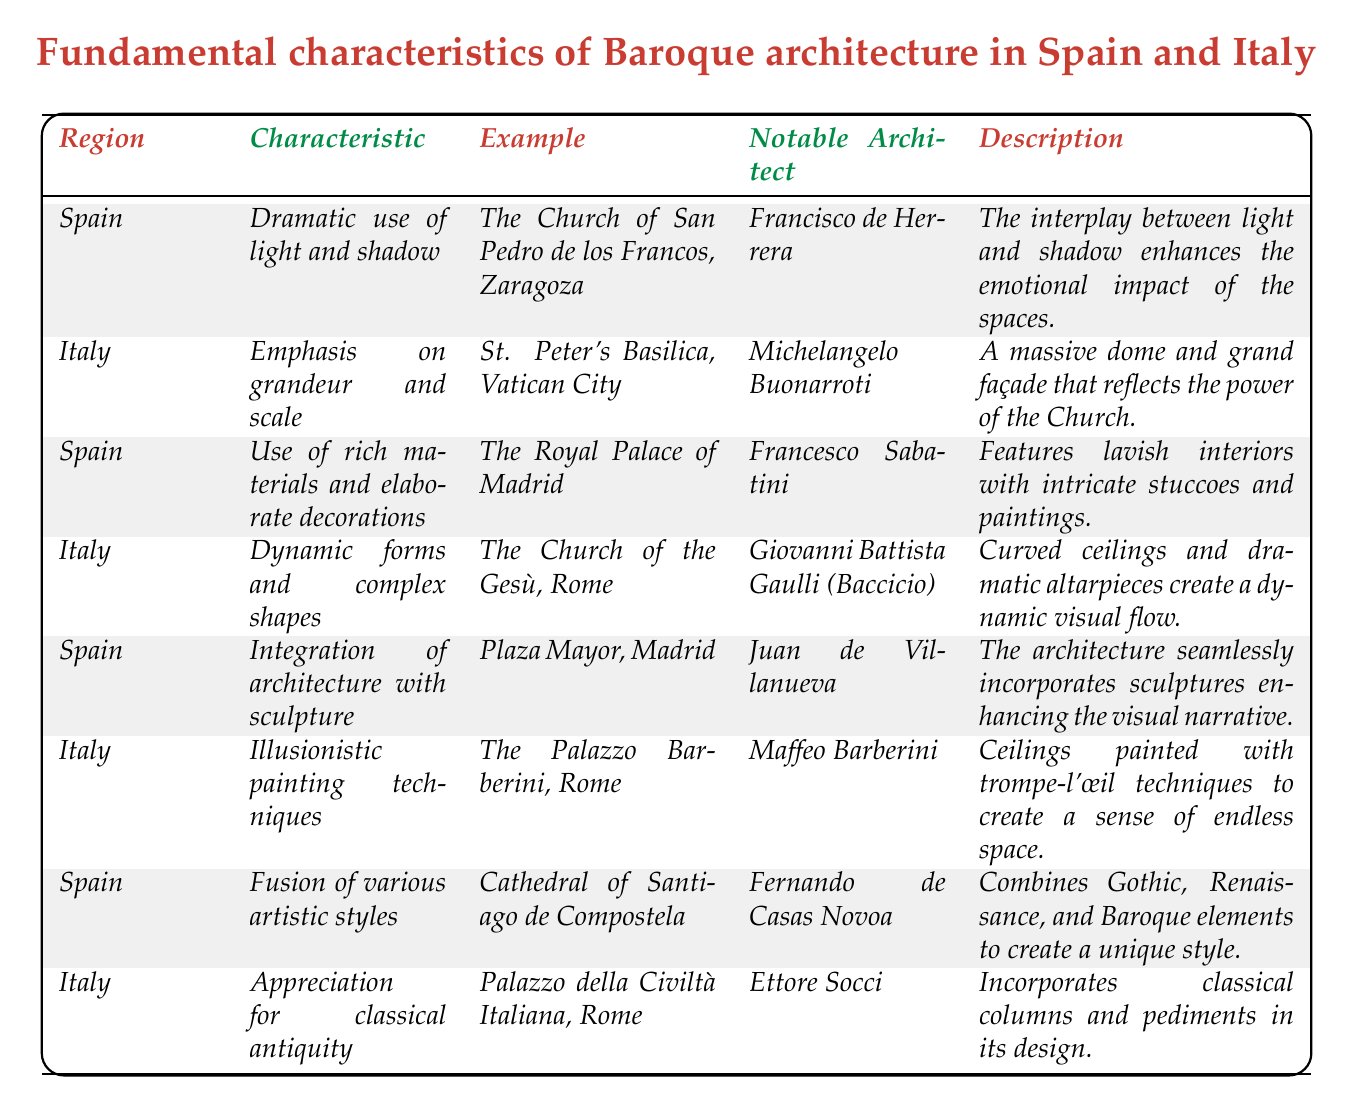What is the notable architect of St. Peter's Basilica? The table lists "Michelangelo Buonarroti" as the notable architect associated with St. Peter's Basilica under the Italy region.
Answer: Michelangelo Buonarroti Which example of Baroque architecture in Spain features rich materials and elaborate decorations? The table indicates that "The Royal Palace of Madrid" is the example in Spain that showcases rich materials and elaborate decorations.
Answer: The Royal Palace of Madrid Are all examples in the Spain region associated with a single architect? There are multiple notable architects listed for Spain's examples, including Francisco de Herrera, Francesco Sabatini, Juan de Villanueva, and Fernando de Casas Novoa, indicating that they are not all from a single architect.
Answer: No Count the total number of characteristics listed for Italy. The table presents 4 specific characteristics under the Italy region, which can be directly counted from the listed entries.
Answer: 4 What characteristic involves the use of dynamic forms and complex shapes? The table states that "Dynamic forms and complex shapes" is a characteristic listed under the Italy region example of "The Church of the Gesù, Rome."
Answer: Dynamic forms and complex shapes Is there any example from Spain that integrates architecture with sculpture? The table confirms that "Plaza Mayor, Madrid" is an example from Spain that integrates architecture with sculpture in its design.
Answer: Yes How many characteristics listed for Spain focus on decorative aspects? There are two characteristics in the Spain region that emphasize decorative aspects: "Dramatic use of light and shadow" and "Use of rich materials and elaborate decorations." By retrieving these from the table, they can be counted as two.
Answer: 2 Which notable architect is associated with the Cathedral of Santiago de Compostela? The table associates "Fernando de Casas Novoa" with the Cathedral of Santiago de Compostela under the Spain category.
Answer: Fernando de Casas Novoa What is the main theme described for the Palazzo Barberini in Rome? The description indicates that the Palazzo Barberini utilizes "Illusionistic painting techniques" to give a sense of endless space.
Answer: Illusionistic painting techniques Which region emphasizes an appreciation for classical antiquity in its architecture? According to the table, the Italy region emphasizes the appreciation for classical antiquity as indicated by the example of "Palazzo della Civiltà Italiana, Rome."
Answer: Italy 